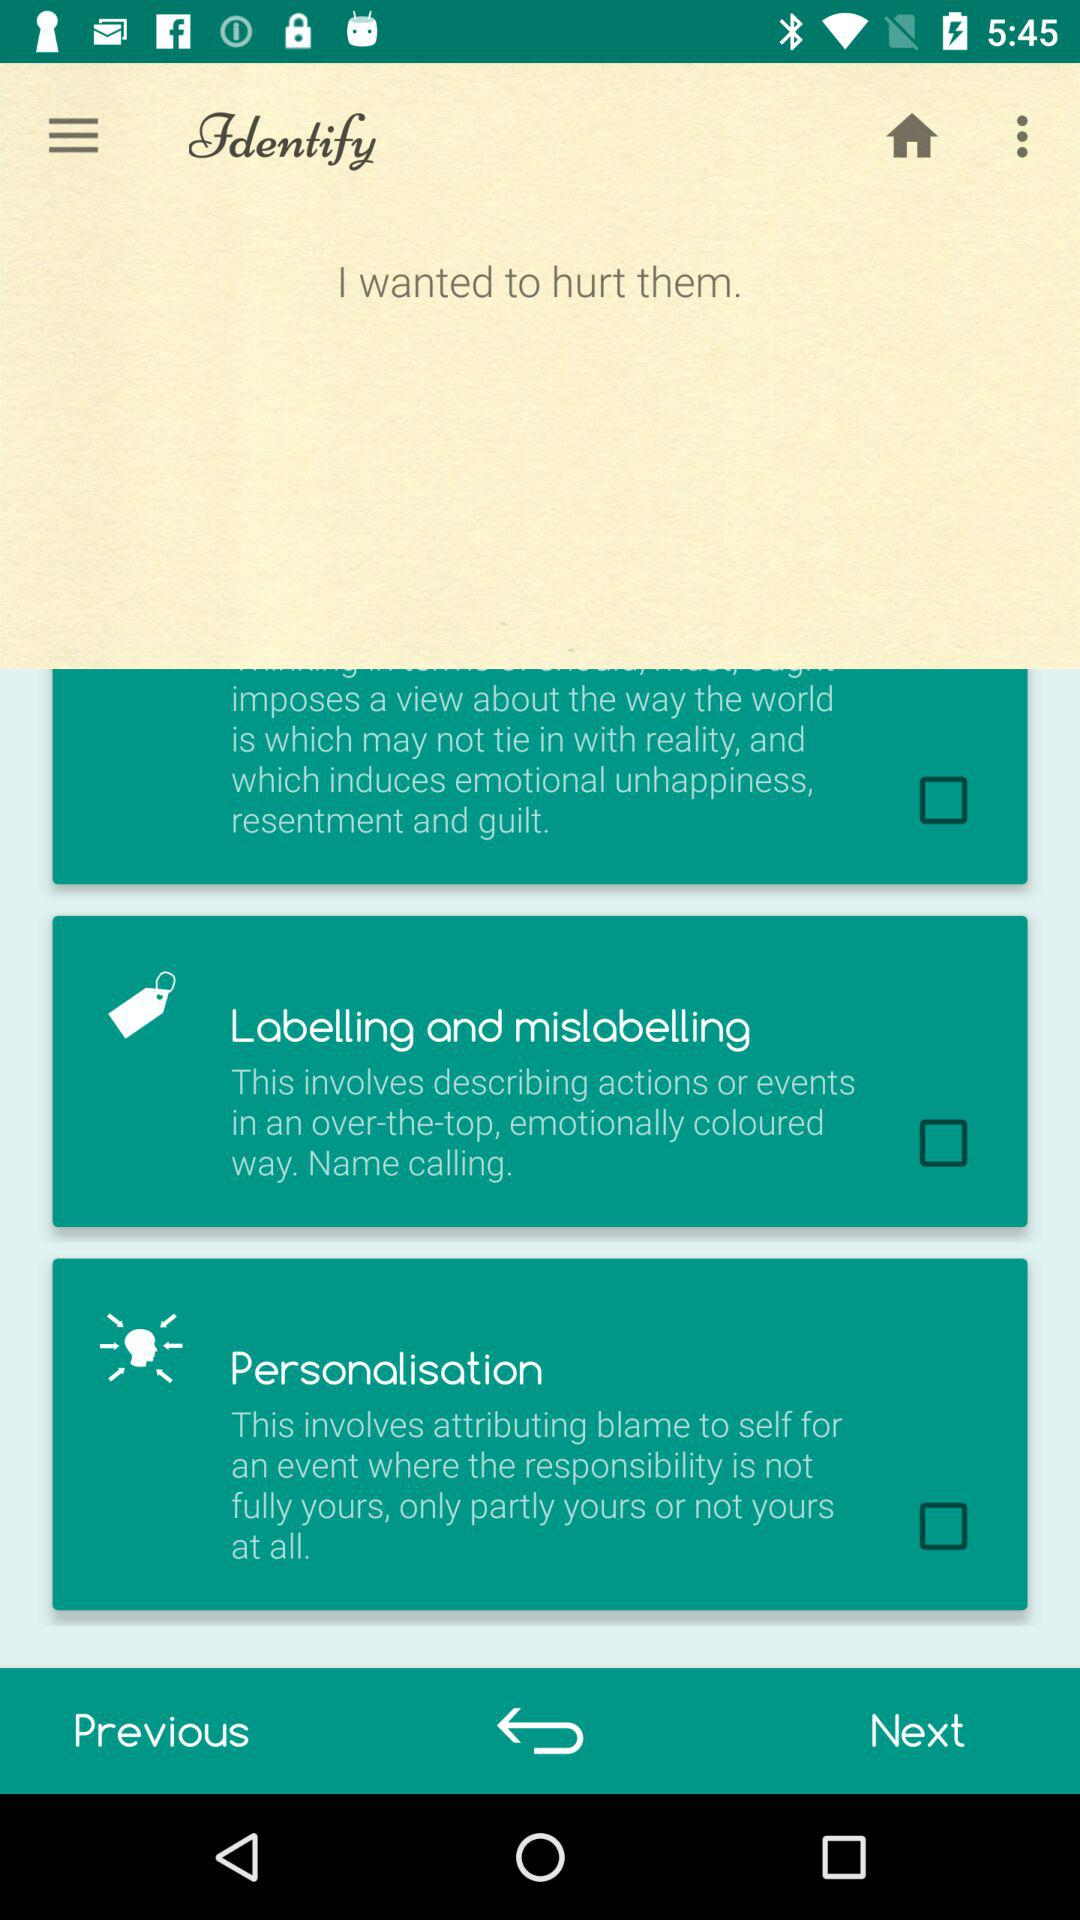What is the status of "Labelling and mislabelling"? The status of "Labelling and mislabelling" is "off". 